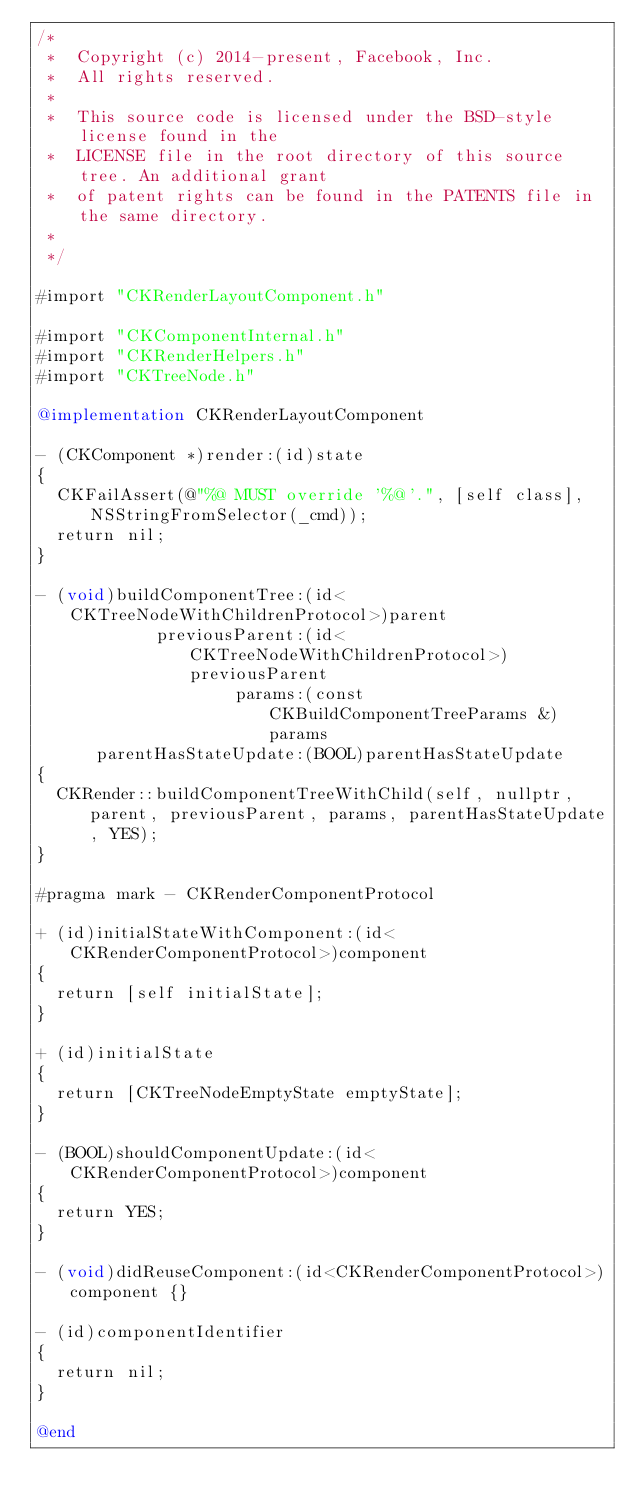<code> <loc_0><loc_0><loc_500><loc_500><_ObjectiveC_>/*
 *  Copyright (c) 2014-present, Facebook, Inc.
 *  All rights reserved.
 *
 *  This source code is licensed under the BSD-style license found in the
 *  LICENSE file in the root directory of this source tree. An additional grant
 *  of patent rights can be found in the PATENTS file in the same directory.
 *
 */

#import "CKRenderLayoutComponent.h"

#import "CKComponentInternal.h"
#import "CKRenderHelpers.h"
#import "CKTreeNode.h"

@implementation CKRenderLayoutComponent

- (CKComponent *)render:(id)state
{
  CKFailAssert(@"%@ MUST override '%@'.", [self class], NSStringFromSelector(_cmd));
  return nil;
}

- (void)buildComponentTree:(id<CKTreeNodeWithChildrenProtocol>)parent
            previousParent:(id<CKTreeNodeWithChildrenProtocol>)previousParent
                    params:(const CKBuildComponentTreeParams &)params
      parentHasStateUpdate:(BOOL)parentHasStateUpdate
{
  CKRender::buildComponentTreeWithChild(self, nullptr, parent, previousParent, params, parentHasStateUpdate, YES);
}

#pragma mark - CKRenderComponentProtocol

+ (id)initialStateWithComponent:(id<CKRenderComponentProtocol>)component
{
  return [self initialState];
}

+ (id)initialState
{
  return [CKTreeNodeEmptyState emptyState];
}

- (BOOL)shouldComponentUpdate:(id<CKRenderComponentProtocol>)component
{
  return YES;
}

- (void)didReuseComponent:(id<CKRenderComponentProtocol>)component {}

- (id)componentIdentifier
{
  return nil;
}

@end
</code> 